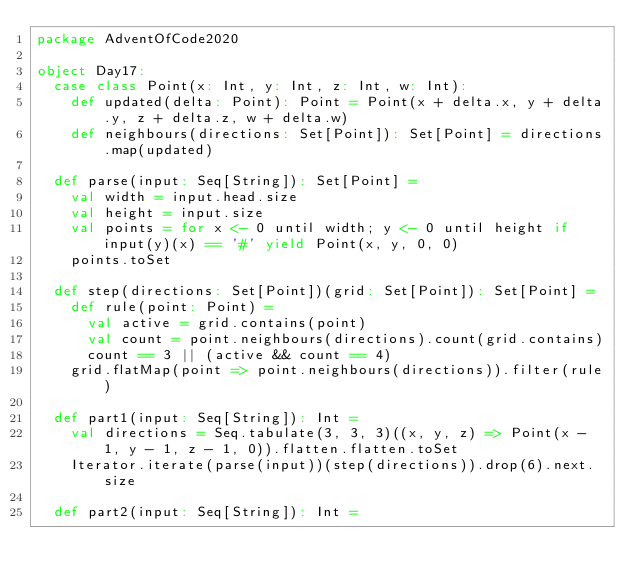Convert code to text. <code><loc_0><loc_0><loc_500><loc_500><_Scala_>package AdventOfCode2020

object Day17:
  case class Point(x: Int, y: Int, z: Int, w: Int):
    def updated(delta: Point): Point = Point(x + delta.x, y + delta.y, z + delta.z, w + delta.w)
    def neighbours(directions: Set[Point]): Set[Point] = directions.map(updated)

  def parse(input: Seq[String]): Set[Point] =
    val width = input.head.size
    val height = input.size
    val points = for x <- 0 until width; y <- 0 until height if input(y)(x) == '#' yield Point(x, y, 0, 0)
    points.toSet

  def step(directions: Set[Point])(grid: Set[Point]): Set[Point] =
    def rule(point: Point) =
      val active = grid.contains(point)
      val count = point.neighbours(directions).count(grid.contains)
      count == 3 || (active && count == 4)
    grid.flatMap(point => point.neighbours(directions)).filter(rule)

  def part1(input: Seq[String]): Int =
    val directions = Seq.tabulate(3, 3, 3)((x, y, z) => Point(x - 1, y - 1, z - 1, 0)).flatten.flatten.toSet
    Iterator.iterate(parse(input))(step(directions)).drop(6).next.size

  def part2(input: Seq[String]): Int =</code> 